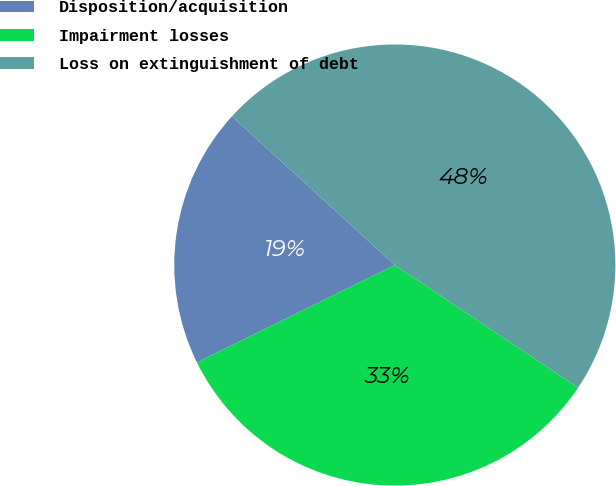Convert chart. <chart><loc_0><loc_0><loc_500><loc_500><pie_chart><fcel>Disposition/acquisition<fcel>Impairment losses<fcel>Loss on extinguishment of debt<nl><fcel>19.05%<fcel>33.33%<fcel>47.62%<nl></chart> 